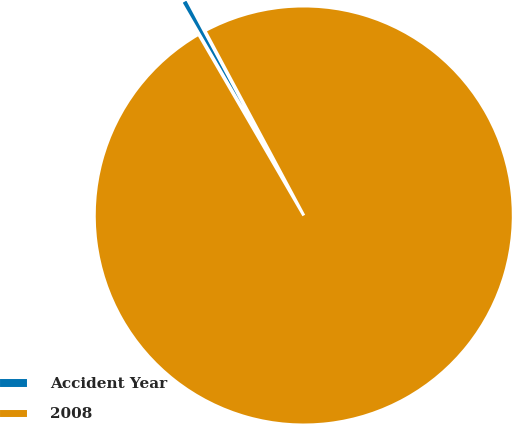Convert chart to OTSL. <chart><loc_0><loc_0><loc_500><loc_500><pie_chart><fcel>Accident Year<fcel>2008<nl><fcel>0.55%<fcel>99.45%<nl></chart> 